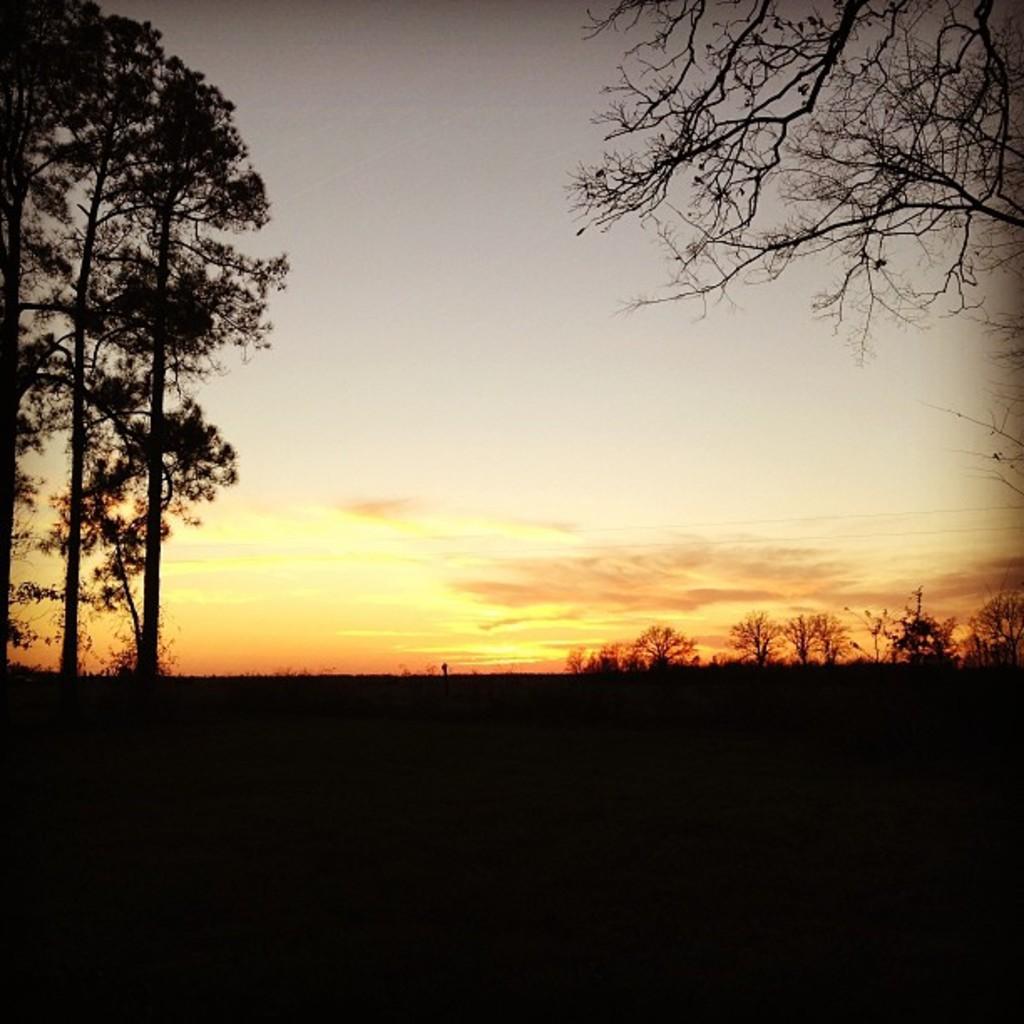Can you describe this image briefly? In this image, I can see grass, trees and the sky. This image taken, maybe on the ground. 